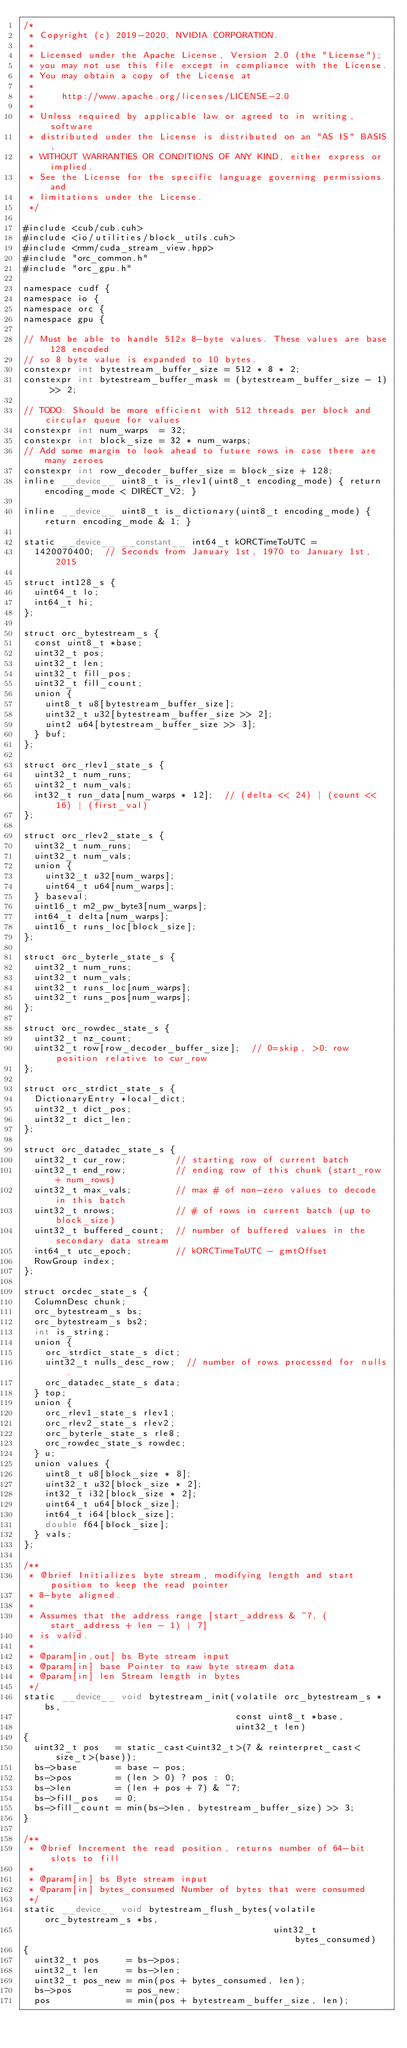Convert code to text. <code><loc_0><loc_0><loc_500><loc_500><_Cuda_>/*
 * Copyright (c) 2019-2020, NVIDIA CORPORATION.
 *
 * Licensed under the Apache License, Version 2.0 (the "License");
 * you may not use this file except in compliance with the License.
 * You may obtain a copy of the License at
 *
 *     http://www.apache.org/licenses/LICENSE-2.0
 *
 * Unless required by applicable law or agreed to in writing, software
 * distributed under the License is distributed on an "AS IS" BASIS,
 * WITHOUT WARRANTIES OR CONDITIONS OF ANY KIND, either express or implied.
 * See the License for the specific language governing permissions and
 * limitations under the License.
 */

#include <cub/cub.cuh>
#include <io/utilities/block_utils.cuh>
#include <rmm/cuda_stream_view.hpp>
#include "orc_common.h"
#include "orc_gpu.h"

namespace cudf {
namespace io {
namespace orc {
namespace gpu {

// Must be able to handle 512x 8-byte values. These values are base 128 encoded
// so 8 byte value is expanded to 10 bytes.
constexpr int bytestream_buffer_size = 512 * 8 * 2;
constexpr int bytestream_buffer_mask = (bytestream_buffer_size - 1) >> 2;

// TODO: Should be more efficient with 512 threads per block and circular queue for values
constexpr int num_warps  = 32;
constexpr int block_size = 32 * num_warps;
// Add some margin to look ahead to future rows in case there are many zeroes
constexpr int row_decoder_buffer_size = block_size + 128;
inline __device__ uint8_t is_rlev1(uint8_t encoding_mode) { return encoding_mode < DIRECT_V2; }

inline __device__ uint8_t is_dictionary(uint8_t encoding_mode) { return encoding_mode & 1; }

static __device__ __constant__ int64_t kORCTimeToUTC =
  1420070400;  // Seconds from January 1st, 1970 to January 1st, 2015

struct int128_s {
  uint64_t lo;
  int64_t hi;
};

struct orc_bytestream_s {
  const uint8_t *base;
  uint32_t pos;
  uint32_t len;
  uint32_t fill_pos;
  uint32_t fill_count;
  union {
    uint8_t u8[bytestream_buffer_size];
    uint32_t u32[bytestream_buffer_size >> 2];
    uint2 u64[bytestream_buffer_size >> 3];
  } buf;
};

struct orc_rlev1_state_s {
  uint32_t num_runs;
  uint32_t num_vals;
  int32_t run_data[num_warps * 12];  // (delta << 24) | (count << 16) | (first_val)
};

struct orc_rlev2_state_s {
  uint32_t num_runs;
  uint32_t num_vals;
  union {
    uint32_t u32[num_warps];
    uint64_t u64[num_warps];
  } baseval;
  uint16_t m2_pw_byte3[num_warps];
  int64_t delta[num_warps];
  uint16_t runs_loc[block_size];
};

struct orc_byterle_state_s {
  uint32_t num_runs;
  uint32_t num_vals;
  uint32_t runs_loc[num_warps];
  uint32_t runs_pos[num_warps];
};

struct orc_rowdec_state_s {
  uint32_t nz_count;
  uint32_t row[row_decoder_buffer_size];  // 0=skip, >0: row position relative to cur_row
};

struct orc_strdict_state_s {
  DictionaryEntry *local_dict;
  uint32_t dict_pos;
  uint32_t dict_len;
};

struct orc_datadec_state_s {
  uint32_t cur_row;         // starting row of current batch
  uint32_t end_row;         // ending row of this chunk (start_row + num_rows)
  uint32_t max_vals;        // max # of non-zero values to decode in this batch
  uint32_t nrows;           // # of rows in current batch (up to block_size)
  uint32_t buffered_count;  // number of buffered values in the secondary data stream
  int64_t utc_epoch;        // kORCTimeToUTC - gmtOffset
  RowGroup index;
};

struct orcdec_state_s {
  ColumnDesc chunk;
  orc_bytestream_s bs;
  orc_bytestream_s bs2;
  int is_string;
  union {
    orc_strdict_state_s dict;
    uint32_t nulls_desc_row;  // number of rows processed for nulls.
    orc_datadec_state_s data;
  } top;
  union {
    orc_rlev1_state_s rlev1;
    orc_rlev2_state_s rlev2;
    orc_byterle_state_s rle8;
    orc_rowdec_state_s rowdec;
  } u;
  union values {
    uint8_t u8[block_size * 8];
    uint32_t u32[block_size * 2];
    int32_t i32[block_size * 2];
    uint64_t u64[block_size];
    int64_t i64[block_size];
    double f64[block_size];
  } vals;
};

/**
 * @brief Initializes byte stream, modifying length and start position to keep the read pointer
 * 8-byte aligned.
 *
 * Assumes that the address range [start_address & ~7, (start_address + len - 1) | 7]
 * is valid.
 *
 * @param[in,out] bs Byte stream input
 * @param[in] base Pointer to raw byte stream data
 * @param[in] len Stream length in bytes
 */
static __device__ void bytestream_init(volatile orc_bytestream_s *bs,
                                       const uint8_t *base,
                                       uint32_t len)
{
  uint32_t pos   = static_cast<uint32_t>(7 & reinterpret_cast<size_t>(base));
  bs->base       = base - pos;
  bs->pos        = (len > 0) ? pos : 0;
  bs->len        = (len + pos + 7) & ~7;
  bs->fill_pos   = 0;
  bs->fill_count = min(bs->len, bytestream_buffer_size) >> 3;
}

/**
 * @brief Increment the read position, returns number of 64-bit slots to fill
 *
 * @param[in] bs Byte stream input
 * @param[in] bytes_consumed Number of bytes that were consumed
 */
static __device__ void bytestream_flush_bytes(volatile orc_bytestream_s *bs,
                                              uint32_t bytes_consumed)
{
  uint32_t pos     = bs->pos;
  uint32_t len     = bs->len;
  uint32_t pos_new = min(pos + bytes_consumed, len);
  bs->pos          = pos_new;
  pos              = min(pos + bytestream_buffer_size, len);</code> 